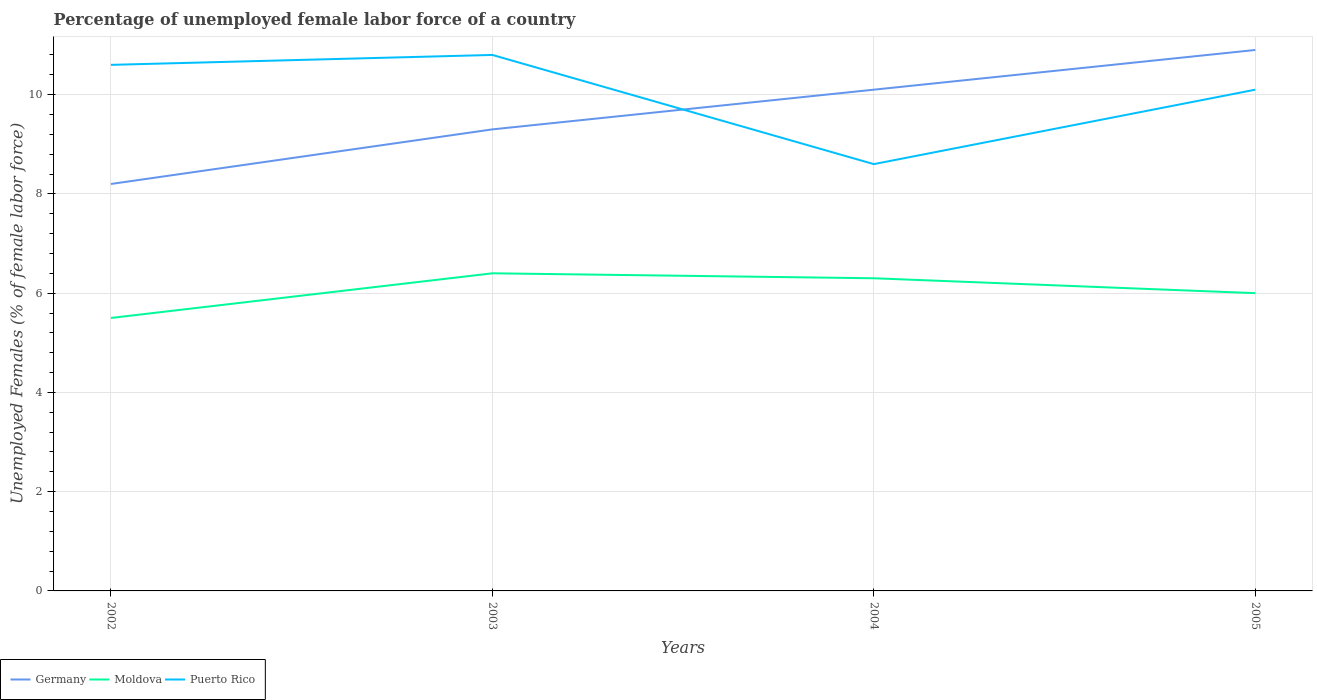Does the line corresponding to Germany intersect with the line corresponding to Puerto Rico?
Provide a short and direct response. Yes. Is the number of lines equal to the number of legend labels?
Your answer should be compact. Yes. In which year was the percentage of unemployed female labor force in Moldova maximum?
Give a very brief answer. 2002. What is the difference between the highest and the second highest percentage of unemployed female labor force in Moldova?
Offer a very short reply. 0.9. Is the percentage of unemployed female labor force in Moldova strictly greater than the percentage of unemployed female labor force in Germany over the years?
Your answer should be compact. Yes. How many lines are there?
Make the answer very short. 3. What is the difference between two consecutive major ticks on the Y-axis?
Your answer should be compact. 2. Are the values on the major ticks of Y-axis written in scientific E-notation?
Keep it short and to the point. No. Does the graph contain grids?
Provide a succinct answer. Yes. How are the legend labels stacked?
Offer a very short reply. Horizontal. What is the title of the graph?
Keep it short and to the point. Percentage of unemployed female labor force of a country. What is the label or title of the Y-axis?
Keep it short and to the point. Unemployed Females (% of female labor force). What is the Unemployed Females (% of female labor force) of Germany in 2002?
Offer a very short reply. 8.2. What is the Unemployed Females (% of female labor force) of Moldova in 2002?
Offer a terse response. 5.5. What is the Unemployed Females (% of female labor force) in Puerto Rico in 2002?
Provide a succinct answer. 10.6. What is the Unemployed Females (% of female labor force) of Germany in 2003?
Provide a short and direct response. 9.3. What is the Unemployed Females (% of female labor force) of Moldova in 2003?
Your answer should be very brief. 6.4. What is the Unemployed Females (% of female labor force) in Puerto Rico in 2003?
Offer a terse response. 10.8. What is the Unemployed Females (% of female labor force) of Germany in 2004?
Make the answer very short. 10.1. What is the Unemployed Females (% of female labor force) in Moldova in 2004?
Give a very brief answer. 6.3. What is the Unemployed Females (% of female labor force) of Puerto Rico in 2004?
Your response must be concise. 8.6. What is the Unemployed Females (% of female labor force) in Germany in 2005?
Ensure brevity in your answer.  10.9. What is the Unemployed Females (% of female labor force) in Puerto Rico in 2005?
Give a very brief answer. 10.1. Across all years, what is the maximum Unemployed Females (% of female labor force) of Germany?
Your answer should be very brief. 10.9. Across all years, what is the maximum Unemployed Females (% of female labor force) in Moldova?
Offer a very short reply. 6.4. Across all years, what is the maximum Unemployed Females (% of female labor force) in Puerto Rico?
Give a very brief answer. 10.8. Across all years, what is the minimum Unemployed Females (% of female labor force) in Germany?
Keep it short and to the point. 8.2. Across all years, what is the minimum Unemployed Females (% of female labor force) in Puerto Rico?
Your answer should be compact. 8.6. What is the total Unemployed Females (% of female labor force) of Germany in the graph?
Give a very brief answer. 38.5. What is the total Unemployed Females (% of female labor force) of Moldova in the graph?
Your answer should be compact. 24.2. What is the total Unemployed Females (% of female labor force) in Puerto Rico in the graph?
Provide a short and direct response. 40.1. What is the difference between the Unemployed Females (% of female labor force) in Moldova in 2002 and that in 2004?
Your answer should be very brief. -0.8. What is the difference between the Unemployed Females (% of female labor force) of Puerto Rico in 2002 and that in 2004?
Offer a terse response. 2. What is the difference between the Unemployed Females (% of female labor force) in Germany in 2002 and that in 2005?
Provide a succinct answer. -2.7. What is the difference between the Unemployed Females (% of female labor force) of Moldova in 2002 and that in 2005?
Your answer should be very brief. -0.5. What is the difference between the Unemployed Females (% of female labor force) of Puerto Rico in 2002 and that in 2005?
Provide a succinct answer. 0.5. What is the difference between the Unemployed Females (% of female labor force) in Puerto Rico in 2003 and that in 2004?
Your response must be concise. 2.2. What is the difference between the Unemployed Females (% of female labor force) in Moldova in 2003 and that in 2005?
Your response must be concise. 0.4. What is the difference between the Unemployed Females (% of female labor force) in Puerto Rico in 2003 and that in 2005?
Your answer should be compact. 0.7. What is the difference between the Unemployed Females (% of female labor force) in Moldova in 2004 and that in 2005?
Keep it short and to the point. 0.3. What is the difference between the Unemployed Females (% of female labor force) of Germany in 2002 and the Unemployed Females (% of female labor force) of Puerto Rico in 2003?
Your answer should be compact. -2.6. What is the difference between the Unemployed Females (% of female labor force) of Moldova in 2002 and the Unemployed Females (% of female labor force) of Puerto Rico in 2003?
Your answer should be compact. -5.3. What is the difference between the Unemployed Females (% of female labor force) in Germany in 2002 and the Unemployed Females (% of female labor force) in Moldova in 2004?
Your response must be concise. 1.9. What is the difference between the Unemployed Females (% of female labor force) in Germany in 2002 and the Unemployed Females (% of female labor force) in Moldova in 2005?
Your answer should be very brief. 2.2. What is the difference between the Unemployed Females (% of female labor force) of Germany in 2002 and the Unemployed Females (% of female labor force) of Puerto Rico in 2005?
Offer a very short reply. -1.9. What is the difference between the Unemployed Females (% of female labor force) of Germany in 2003 and the Unemployed Females (% of female labor force) of Puerto Rico in 2004?
Make the answer very short. 0.7. What is the difference between the Unemployed Females (% of female labor force) in Moldova in 2003 and the Unemployed Females (% of female labor force) in Puerto Rico in 2004?
Make the answer very short. -2.2. What is the difference between the Unemployed Females (% of female labor force) in Germany in 2003 and the Unemployed Females (% of female labor force) in Moldova in 2005?
Your answer should be very brief. 3.3. What is the difference between the Unemployed Females (% of female labor force) of Moldova in 2003 and the Unemployed Females (% of female labor force) of Puerto Rico in 2005?
Your answer should be very brief. -3.7. What is the difference between the Unemployed Females (% of female labor force) of Germany in 2004 and the Unemployed Females (% of female labor force) of Moldova in 2005?
Offer a very short reply. 4.1. What is the difference between the Unemployed Females (% of female labor force) in Moldova in 2004 and the Unemployed Females (% of female labor force) in Puerto Rico in 2005?
Provide a short and direct response. -3.8. What is the average Unemployed Females (% of female labor force) in Germany per year?
Make the answer very short. 9.62. What is the average Unemployed Females (% of female labor force) of Moldova per year?
Your answer should be compact. 6.05. What is the average Unemployed Females (% of female labor force) of Puerto Rico per year?
Your answer should be compact. 10.03. In the year 2003, what is the difference between the Unemployed Females (% of female labor force) of Moldova and Unemployed Females (% of female labor force) of Puerto Rico?
Provide a short and direct response. -4.4. In the year 2004, what is the difference between the Unemployed Females (% of female labor force) in Germany and Unemployed Females (% of female labor force) in Moldova?
Offer a terse response. 3.8. In the year 2005, what is the difference between the Unemployed Females (% of female labor force) of Moldova and Unemployed Females (% of female labor force) of Puerto Rico?
Keep it short and to the point. -4.1. What is the ratio of the Unemployed Females (% of female labor force) in Germany in 2002 to that in 2003?
Provide a short and direct response. 0.88. What is the ratio of the Unemployed Females (% of female labor force) of Moldova in 2002 to that in 2003?
Your response must be concise. 0.86. What is the ratio of the Unemployed Females (% of female labor force) of Puerto Rico in 2002 to that in 2003?
Your answer should be compact. 0.98. What is the ratio of the Unemployed Females (% of female labor force) in Germany in 2002 to that in 2004?
Provide a short and direct response. 0.81. What is the ratio of the Unemployed Females (% of female labor force) in Moldova in 2002 to that in 2004?
Ensure brevity in your answer.  0.87. What is the ratio of the Unemployed Females (% of female labor force) of Puerto Rico in 2002 to that in 2004?
Your answer should be compact. 1.23. What is the ratio of the Unemployed Females (% of female labor force) of Germany in 2002 to that in 2005?
Offer a terse response. 0.75. What is the ratio of the Unemployed Females (% of female labor force) in Moldova in 2002 to that in 2005?
Your response must be concise. 0.92. What is the ratio of the Unemployed Females (% of female labor force) in Puerto Rico in 2002 to that in 2005?
Your answer should be very brief. 1.05. What is the ratio of the Unemployed Females (% of female labor force) in Germany in 2003 to that in 2004?
Offer a very short reply. 0.92. What is the ratio of the Unemployed Females (% of female labor force) of Moldova in 2003 to that in 2004?
Your answer should be compact. 1.02. What is the ratio of the Unemployed Females (% of female labor force) of Puerto Rico in 2003 to that in 2004?
Offer a terse response. 1.26. What is the ratio of the Unemployed Females (% of female labor force) of Germany in 2003 to that in 2005?
Make the answer very short. 0.85. What is the ratio of the Unemployed Females (% of female labor force) in Moldova in 2003 to that in 2005?
Provide a succinct answer. 1.07. What is the ratio of the Unemployed Females (% of female labor force) of Puerto Rico in 2003 to that in 2005?
Offer a terse response. 1.07. What is the ratio of the Unemployed Females (% of female labor force) in Germany in 2004 to that in 2005?
Your response must be concise. 0.93. What is the ratio of the Unemployed Females (% of female labor force) in Puerto Rico in 2004 to that in 2005?
Offer a terse response. 0.85. What is the difference between the highest and the second highest Unemployed Females (% of female labor force) in Germany?
Give a very brief answer. 0.8. What is the difference between the highest and the lowest Unemployed Females (% of female labor force) in Puerto Rico?
Provide a short and direct response. 2.2. 